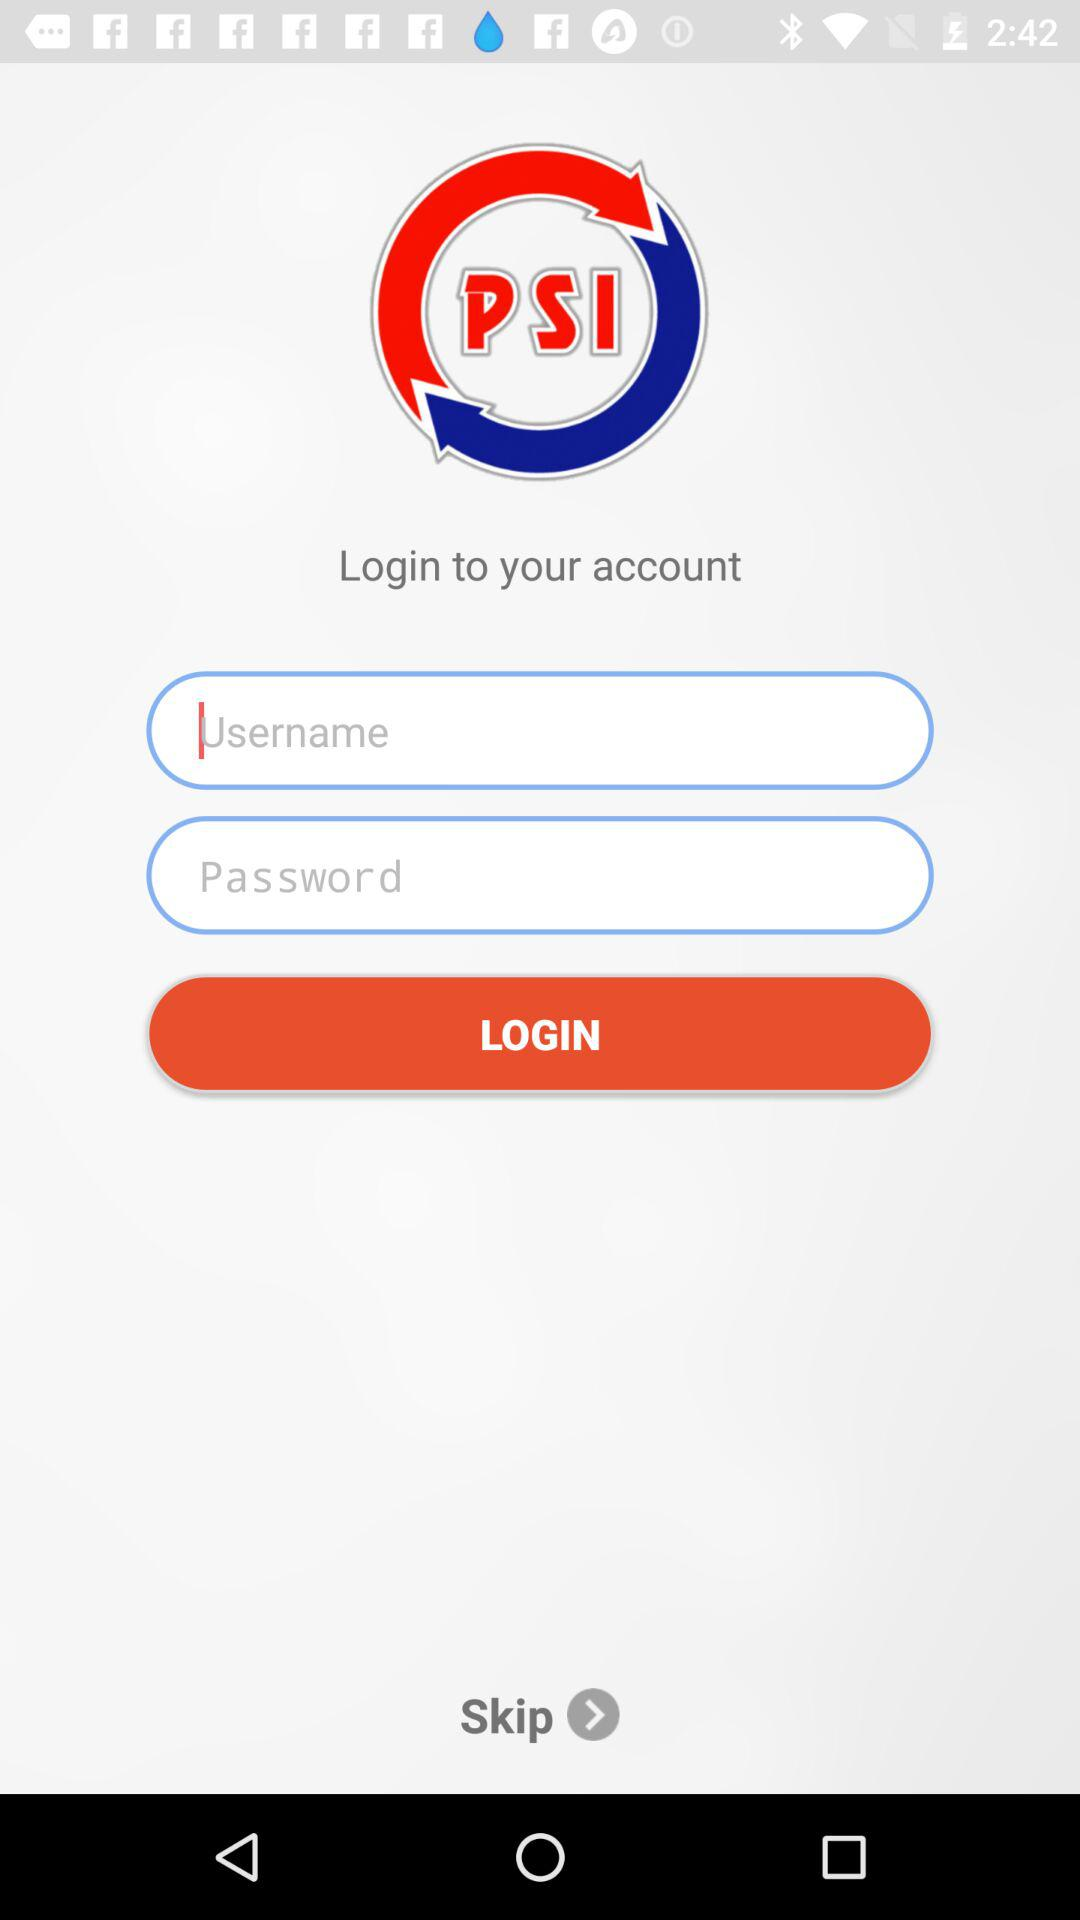What is the application name? The application name is "PSI". 